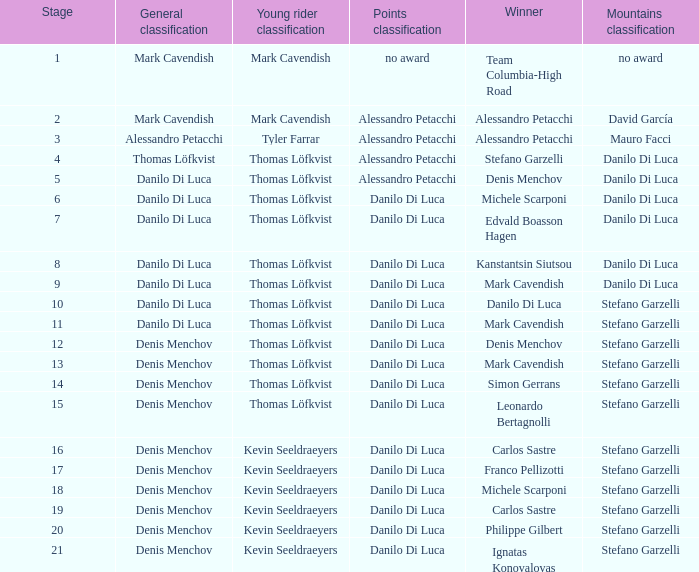Would you mind parsing the complete table? {'header': ['Stage', 'General classification', 'Young rider classification', 'Points classification', 'Winner', 'Mountains classification'], 'rows': [['1', 'Mark Cavendish', 'Mark Cavendish', 'no award', 'Team Columbia-High Road', 'no award'], ['2', 'Mark Cavendish', 'Mark Cavendish', 'Alessandro Petacchi', 'Alessandro Petacchi', 'David García'], ['3', 'Alessandro Petacchi', 'Tyler Farrar', 'Alessandro Petacchi', 'Alessandro Petacchi', 'Mauro Facci'], ['4', 'Thomas Löfkvist', 'Thomas Löfkvist', 'Alessandro Petacchi', 'Stefano Garzelli', 'Danilo Di Luca'], ['5', 'Danilo Di Luca', 'Thomas Löfkvist', 'Alessandro Petacchi', 'Denis Menchov', 'Danilo Di Luca'], ['6', 'Danilo Di Luca', 'Thomas Löfkvist', 'Danilo Di Luca', 'Michele Scarponi', 'Danilo Di Luca'], ['7', 'Danilo Di Luca', 'Thomas Löfkvist', 'Danilo Di Luca', 'Edvald Boasson Hagen', 'Danilo Di Luca'], ['8', 'Danilo Di Luca', 'Thomas Löfkvist', 'Danilo Di Luca', 'Kanstantsin Siutsou', 'Danilo Di Luca'], ['9', 'Danilo Di Luca', 'Thomas Löfkvist', 'Danilo Di Luca', 'Mark Cavendish', 'Danilo Di Luca'], ['10', 'Danilo Di Luca', 'Thomas Löfkvist', 'Danilo Di Luca', 'Danilo Di Luca', 'Stefano Garzelli'], ['11', 'Danilo Di Luca', 'Thomas Löfkvist', 'Danilo Di Luca', 'Mark Cavendish', 'Stefano Garzelli'], ['12', 'Denis Menchov', 'Thomas Löfkvist', 'Danilo Di Luca', 'Denis Menchov', 'Stefano Garzelli'], ['13', 'Denis Menchov', 'Thomas Löfkvist', 'Danilo Di Luca', 'Mark Cavendish', 'Stefano Garzelli'], ['14', 'Denis Menchov', 'Thomas Löfkvist', 'Danilo Di Luca', 'Simon Gerrans', 'Stefano Garzelli'], ['15', 'Denis Menchov', 'Thomas Löfkvist', 'Danilo Di Luca', 'Leonardo Bertagnolli', 'Stefano Garzelli'], ['16', 'Denis Menchov', 'Kevin Seeldraeyers', 'Danilo Di Luca', 'Carlos Sastre', 'Stefano Garzelli'], ['17', 'Denis Menchov', 'Kevin Seeldraeyers', 'Danilo Di Luca', 'Franco Pellizotti', 'Stefano Garzelli'], ['18', 'Denis Menchov', 'Kevin Seeldraeyers', 'Danilo Di Luca', 'Michele Scarponi', 'Stefano Garzelli'], ['19', 'Denis Menchov', 'Kevin Seeldraeyers', 'Danilo Di Luca', 'Carlos Sastre', 'Stefano Garzelli'], ['20', 'Denis Menchov', 'Kevin Seeldraeyers', 'Danilo Di Luca', 'Philippe Gilbert', 'Stefano Garzelli'], ['21', 'Denis Menchov', 'Kevin Seeldraeyers', 'Danilo Di Luca', 'Ignatas Konovalovas', 'Stefano Garzelli']]} When philippe gilbert is the winner who is the points classification? Danilo Di Luca. 